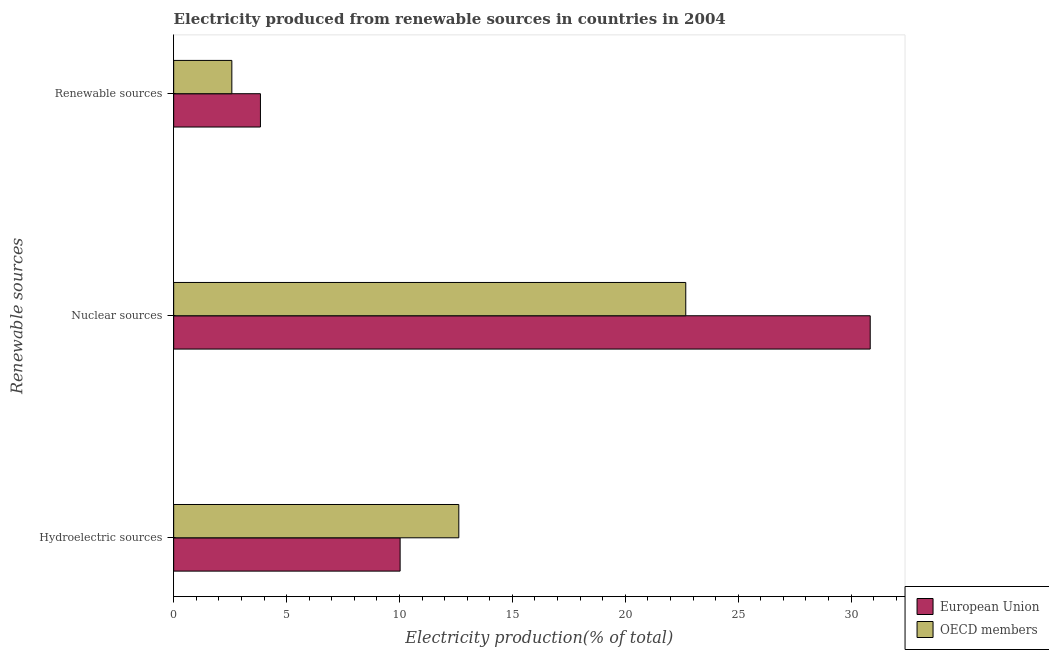How many groups of bars are there?
Your answer should be very brief. 3. How many bars are there on the 3rd tick from the top?
Give a very brief answer. 2. What is the label of the 1st group of bars from the top?
Keep it short and to the point. Renewable sources. What is the percentage of electricity produced by hydroelectric sources in European Union?
Your answer should be very brief. 10.03. Across all countries, what is the maximum percentage of electricity produced by hydroelectric sources?
Provide a succinct answer. 12.63. Across all countries, what is the minimum percentage of electricity produced by hydroelectric sources?
Provide a short and direct response. 10.03. What is the total percentage of electricity produced by hydroelectric sources in the graph?
Keep it short and to the point. 22.66. What is the difference between the percentage of electricity produced by hydroelectric sources in OECD members and that in European Union?
Provide a succinct answer. 2.6. What is the difference between the percentage of electricity produced by nuclear sources in OECD members and the percentage of electricity produced by hydroelectric sources in European Union?
Provide a succinct answer. 12.65. What is the average percentage of electricity produced by nuclear sources per country?
Provide a succinct answer. 26.76. What is the difference between the percentage of electricity produced by renewable sources and percentage of electricity produced by hydroelectric sources in European Union?
Offer a terse response. -6.19. What is the ratio of the percentage of electricity produced by renewable sources in OECD members to that in European Union?
Offer a very short reply. 0.67. Is the percentage of electricity produced by renewable sources in European Union less than that in OECD members?
Your answer should be very brief. No. Is the difference between the percentage of electricity produced by nuclear sources in European Union and OECD members greater than the difference between the percentage of electricity produced by hydroelectric sources in European Union and OECD members?
Your answer should be compact. Yes. What is the difference between the highest and the second highest percentage of electricity produced by nuclear sources?
Provide a succinct answer. 8.17. What is the difference between the highest and the lowest percentage of electricity produced by nuclear sources?
Make the answer very short. 8.17. Is the sum of the percentage of electricity produced by renewable sources in OECD members and European Union greater than the maximum percentage of electricity produced by hydroelectric sources across all countries?
Provide a succinct answer. No. Is it the case that in every country, the sum of the percentage of electricity produced by hydroelectric sources and percentage of electricity produced by nuclear sources is greater than the percentage of electricity produced by renewable sources?
Ensure brevity in your answer.  Yes. How many bars are there?
Ensure brevity in your answer.  6. What is the difference between two consecutive major ticks on the X-axis?
Make the answer very short. 5. How many legend labels are there?
Offer a very short reply. 2. How are the legend labels stacked?
Give a very brief answer. Vertical. What is the title of the graph?
Your response must be concise. Electricity produced from renewable sources in countries in 2004. Does "Puerto Rico" appear as one of the legend labels in the graph?
Your answer should be compact. No. What is the label or title of the Y-axis?
Offer a very short reply. Renewable sources. What is the Electricity production(% of total) of European Union in Hydroelectric sources?
Offer a very short reply. 10.03. What is the Electricity production(% of total) of OECD members in Hydroelectric sources?
Your response must be concise. 12.63. What is the Electricity production(% of total) in European Union in Nuclear sources?
Your response must be concise. 30.85. What is the Electricity production(% of total) of OECD members in Nuclear sources?
Your answer should be compact. 22.68. What is the Electricity production(% of total) of European Union in Renewable sources?
Make the answer very short. 3.84. What is the Electricity production(% of total) of OECD members in Renewable sources?
Make the answer very short. 2.58. Across all Renewable sources, what is the maximum Electricity production(% of total) in European Union?
Your answer should be compact. 30.85. Across all Renewable sources, what is the maximum Electricity production(% of total) of OECD members?
Offer a terse response. 22.68. Across all Renewable sources, what is the minimum Electricity production(% of total) of European Union?
Your answer should be compact. 3.84. Across all Renewable sources, what is the minimum Electricity production(% of total) in OECD members?
Ensure brevity in your answer.  2.58. What is the total Electricity production(% of total) of European Union in the graph?
Your answer should be very brief. 44.72. What is the total Electricity production(% of total) of OECD members in the graph?
Your answer should be very brief. 37.88. What is the difference between the Electricity production(% of total) in European Union in Hydroelectric sources and that in Nuclear sources?
Give a very brief answer. -20.82. What is the difference between the Electricity production(% of total) of OECD members in Hydroelectric sources and that in Nuclear sources?
Provide a short and direct response. -10.05. What is the difference between the Electricity production(% of total) of European Union in Hydroelectric sources and that in Renewable sources?
Make the answer very short. 6.19. What is the difference between the Electricity production(% of total) in OECD members in Hydroelectric sources and that in Renewable sources?
Keep it short and to the point. 10.05. What is the difference between the Electricity production(% of total) of European Union in Nuclear sources and that in Renewable sources?
Offer a very short reply. 27. What is the difference between the Electricity production(% of total) in OECD members in Nuclear sources and that in Renewable sources?
Make the answer very short. 20.1. What is the difference between the Electricity production(% of total) of European Union in Hydroelectric sources and the Electricity production(% of total) of OECD members in Nuclear sources?
Ensure brevity in your answer.  -12.65. What is the difference between the Electricity production(% of total) of European Union in Hydroelectric sources and the Electricity production(% of total) of OECD members in Renewable sources?
Keep it short and to the point. 7.45. What is the difference between the Electricity production(% of total) of European Union in Nuclear sources and the Electricity production(% of total) of OECD members in Renewable sources?
Ensure brevity in your answer.  28.27. What is the average Electricity production(% of total) in European Union per Renewable sources?
Ensure brevity in your answer.  14.91. What is the average Electricity production(% of total) of OECD members per Renewable sources?
Your answer should be compact. 12.63. What is the difference between the Electricity production(% of total) in European Union and Electricity production(% of total) in OECD members in Hydroelectric sources?
Keep it short and to the point. -2.6. What is the difference between the Electricity production(% of total) of European Union and Electricity production(% of total) of OECD members in Nuclear sources?
Make the answer very short. 8.17. What is the difference between the Electricity production(% of total) of European Union and Electricity production(% of total) of OECD members in Renewable sources?
Your response must be concise. 1.27. What is the ratio of the Electricity production(% of total) of European Union in Hydroelectric sources to that in Nuclear sources?
Offer a very short reply. 0.33. What is the ratio of the Electricity production(% of total) of OECD members in Hydroelectric sources to that in Nuclear sources?
Give a very brief answer. 0.56. What is the ratio of the Electricity production(% of total) of European Union in Hydroelectric sources to that in Renewable sources?
Ensure brevity in your answer.  2.61. What is the ratio of the Electricity production(% of total) in OECD members in Hydroelectric sources to that in Renewable sources?
Your answer should be very brief. 4.9. What is the ratio of the Electricity production(% of total) in European Union in Nuclear sources to that in Renewable sources?
Offer a terse response. 8.03. What is the ratio of the Electricity production(% of total) in OECD members in Nuclear sources to that in Renewable sources?
Offer a terse response. 8.8. What is the difference between the highest and the second highest Electricity production(% of total) in European Union?
Make the answer very short. 20.82. What is the difference between the highest and the second highest Electricity production(% of total) in OECD members?
Your answer should be very brief. 10.05. What is the difference between the highest and the lowest Electricity production(% of total) of European Union?
Offer a terse response. 27. What is the difference between the highest and the lowest Electricity production(% of total) of OECD members?
Ensure brevity in your answer.  20.1. 